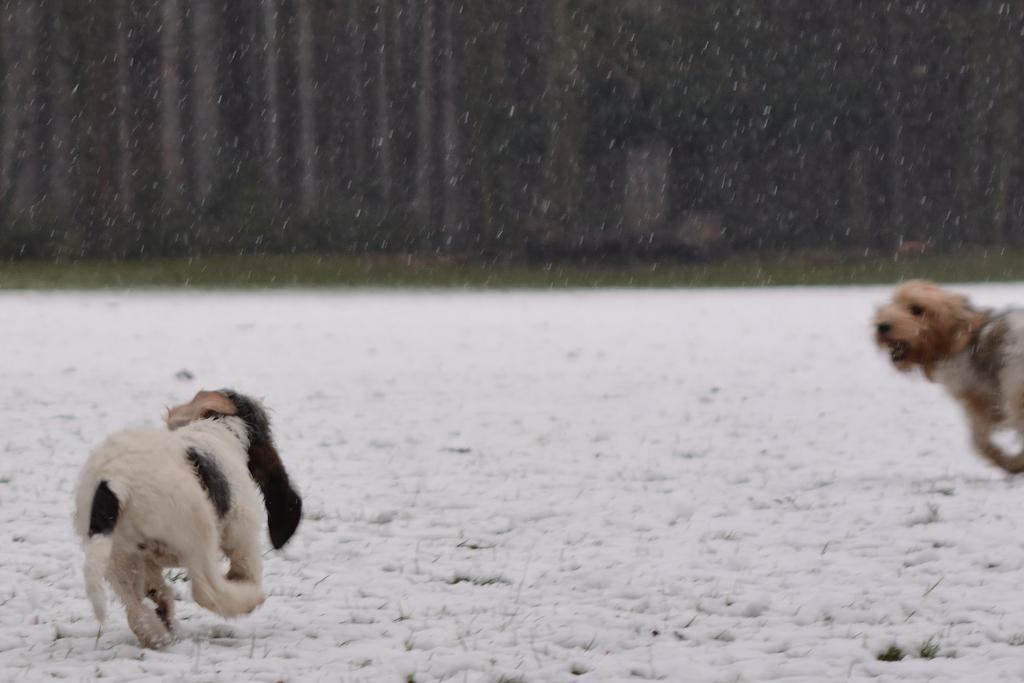How many dogs are present in the image? There are two dogs in the image. What are the dogs doing in the image? The dogs are running on the snow. Can you describe the color pattern of one of the dogs? One of the dogs is white and black in color. What is the weather condition in the image? There is snowfall visible in the image. What can be seen in the background of the image? There are trees in the background of the image. Where is the shop located in the image? There is no shop present in the image; it features two dogs running on the snow. Can you tell me how many items the dogs have in their pockets? Dogs do not have pockets, so it is not possible to determine the number of items they have in their pockets. 